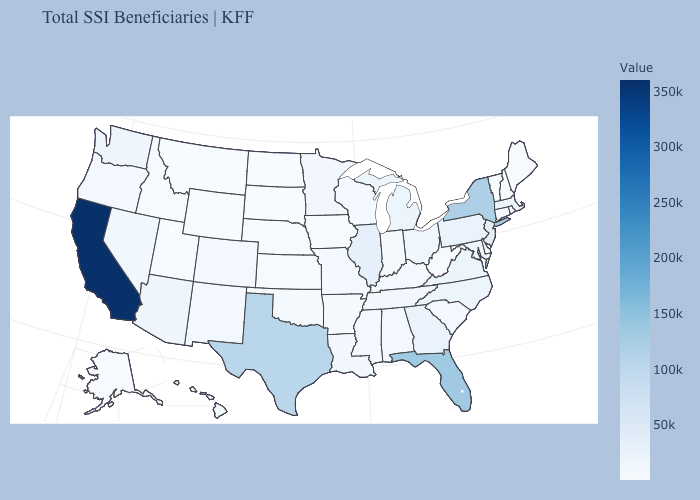Which states have the lowest value in the Northeast?
Answer briefly. New Hampshire. Among the states that border Nevada , does Utah have the lowest value?
Be succinct. No. Which states hav the highest value in the Northeast?
Give a very brief answer. New York. Does Ohio have a lower value than California?
Concise answer only. Yes. 